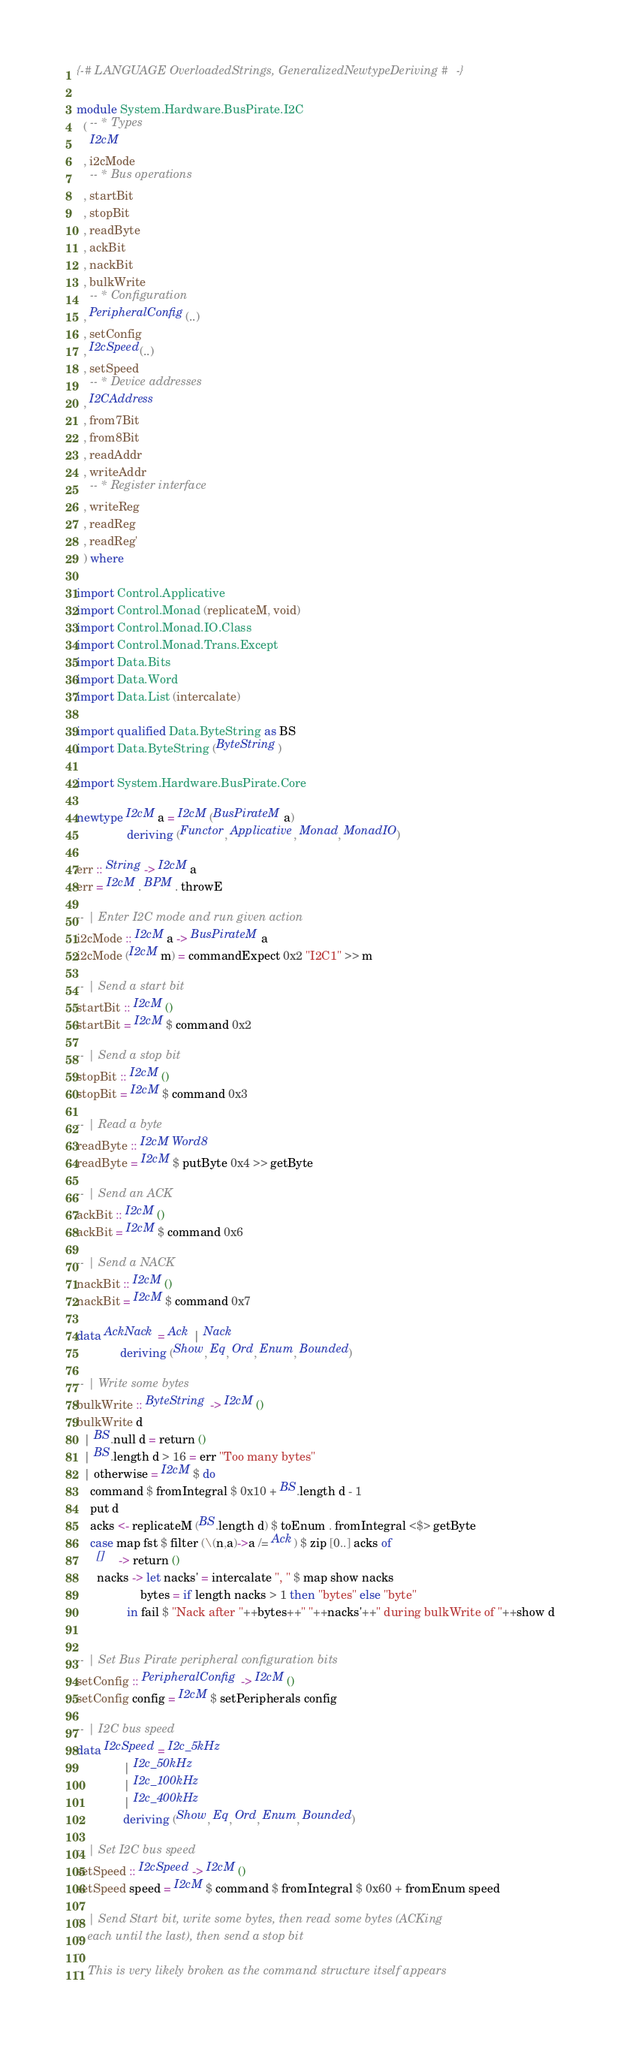Convert code to text. <code><loc_0><loc_0><loc_500><loc_500><_Haskell_>{-# LANGUAGE OverloadedStrings, GeneralizedNewtypeDeriving #-}

module System.Hardware.BusPirate.I2C
  ( -- * Types
    I2cM
  , i2cMode
    -- * Bus operations
  , startBit
  , stopBit
  , readByte
  , ackBit
  , nackBit
  , bulkWrite
    -- * Configuration
  , PeripheralConfig(..)
  , setConfig
  , I2cSpeed(..)
  , setSpeed
    -- * Device addresses
  , I2CAddress
  , from7Bit
  , from8Bit
  , readAddr
  , writeAddr
    -- * Register interface
  , writeReg
  , readReg
  , readReg'
  ) where

import Control.Applicative
import Control.Monad (replicateM, void)
import Control.Monad.IO.Class
import Control.Monad.Trans.Except
import Data.Bits
import Data.Word
import Data.List (intercalate)

import qualified Data.ByteString as BS
import Data.ByteString (ByteString)

import System.Hardware.BusPirate.Core

newtype I2cM a = I2cM (BusPirateM a)
               deriving (Functor, Applicative, Monad, MonadIO)

err :: String -> I2cM a
err = I2cM . BPM . throwE

-- | Enter I2C mode and run given action
i2cMode :: I2cM a -> BusPirateM a
i2cMode (I2cM m) = commandExpect 0x2 "I2C1" >> m

-- | Send a start bit
startBit :: I2cM ()
startBit = I2cM $ command 0x2

-- | Send a stop bit
stopBit :: I2cM ()
stopBit = I2cM $ command 0x3

-- | Read a byte
readByte :: I2cM Word8
readByte = I2cM $ putByte 0x4 >> getByte

-- | Send an ACK
ackBit :: I2cM ()
ackBit = I2cM $ command 0x6

-- | Send a NACK
nackBit :: I2cM ()
nackBit = I2cM $ command 0x7

data AckNack = Ack | Nack
             deriving (Show, Eq, Ord, Enum, Bounded)

-- | Write some bytes
bulkWrite :: ByteString -> I2cM ()
bulkWrite d
  | BS.null d = return ()
  | BS.length d > 16 = err "Too many bytes"
  | otherwise = I2cM $ do
    command $ fromIntegral $ 0x10 + BS.length d - 1
    put d
    acks <- replicateM (BS.length d) $ toEnum . fromIntegral <$> getByte
    case map fst $ filter (\(n,a)->a /= Ack) $ zip [0..] acks of
      []    -> return ()
      nacks -> let nacks' = intercalate ", " $ map show nacks
                   bytes = if length nacks > 1 then "bytes" else "byte"
               in fail $ "Nack after "++bytes++" "++nacks'++" during bulkWrite of "++show d


-- | Set Bus Pirate peripheral configuration bits
setConfig :: PeripheralConfig -> I2cM ()
setConfig config = I2cM $ setPeripherals config

-- | I2C bus speed
data I2cSpeed = I2c_5kHz
              | I2c_50kHz
              | I2c_100kHz
              | I2c_400kHz
              deriving (Show, Eq, Ord, Enum, Bounded)

-- | Set I2C bus speed
setSpeed :: I2cSpeed -> I2cM ()
setSpeed speed = I2cM $ command $ fromIntegral $ 0x60 + fromEnum speed

-- | Send Start bit, write some bytes, then read some bytes (ACKing
-- each until the last), then send a stop bit
--
-- This is very likely broken as the command structure itself appears</code> 